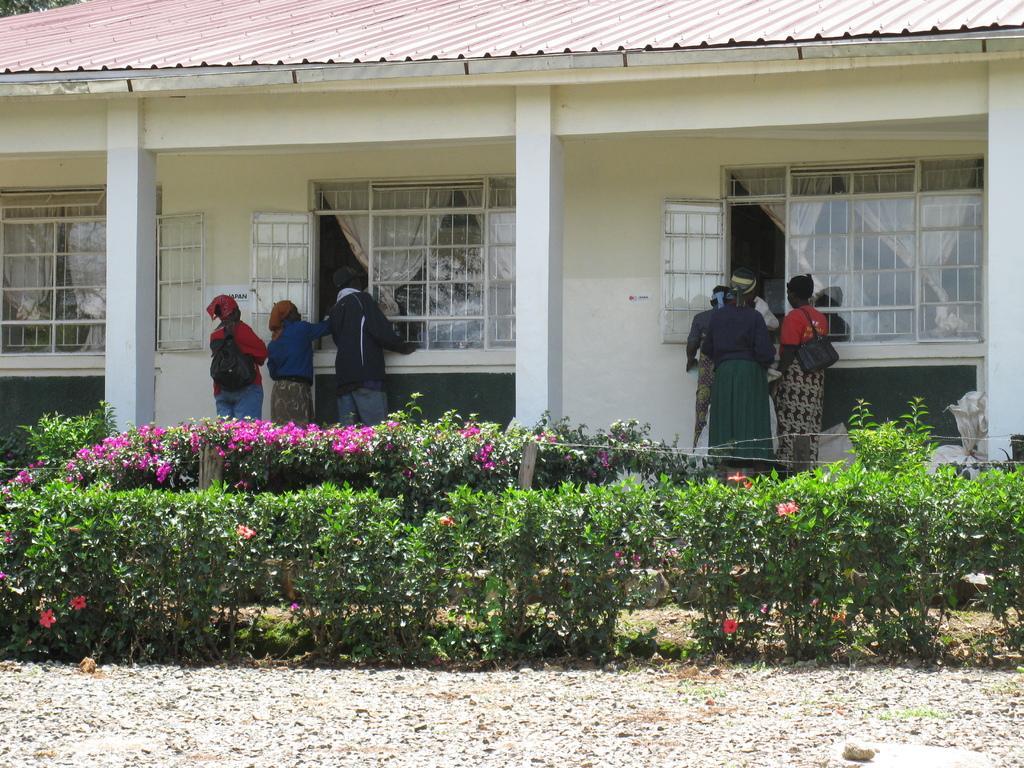How would you summarize this image in a sentence or two? In this image in the center there are plants and in the background there are persons standing and there is a building and there are windows, behind the windows there are curtains which are white in colour. 